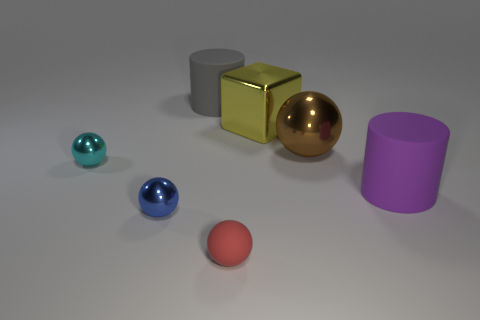What shape is the big rubber thing that is on the right side of the cylinder that is left of the small red object?
Your answer should be very brief. Cylinder. There is a big rubber thing in front of the gray object; what shape is it?
Your response must be concise. Cylinder. How many objects are to the right of the cube and on the left side of the yellow cube?
Offer a very short reply. 0. The blue sphere that is made of the same material as the small cyan object is what size?
Your answer should be compact. Small. What is the size of the red rubber thing?
Make the answer very short. Small. What material is the large cube?
Make the answer very short. Metal. There is a cylinder that is on the left side of the purple object; is its size the same as the purple rubber thing?
Provide a short and direct response. Yes. How many objects are tiny blue balls or brown metallic balls?
Offer a very short reply. 2. There is a ball that is right of the blue metal ball and behind the tiny red thing; what is its size?
Give a very brief answer. Large. How many tiny purple things are there?
Keep it short and to the point. 0. 